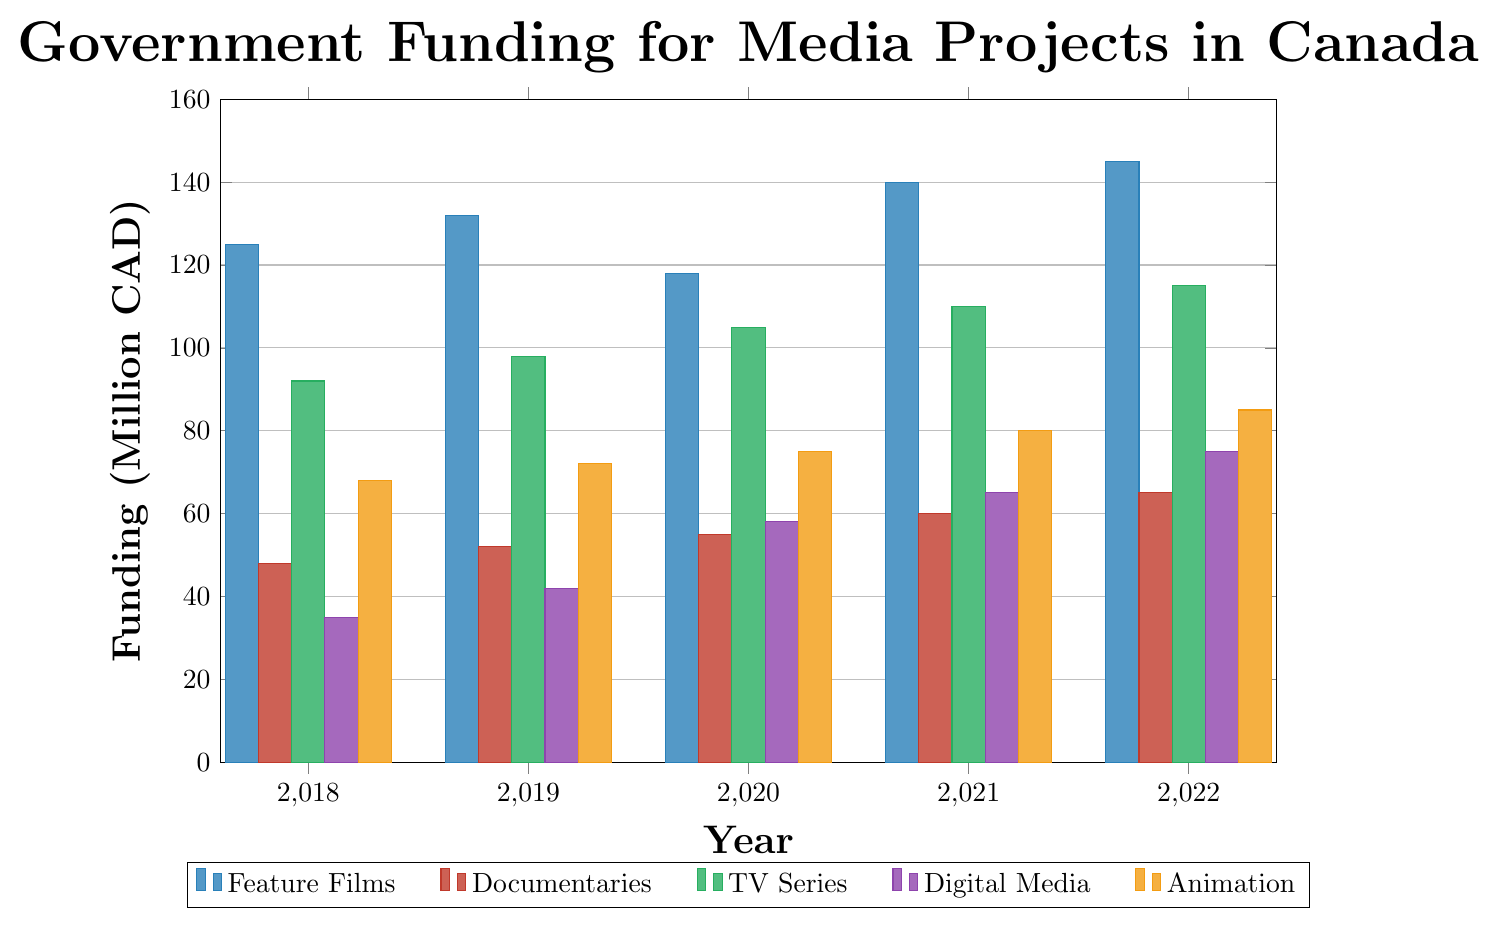How much funding was allocated to Feature Films in 2019? Locate the bar corresponding to Feature Films for the year 2019; the height represents the funding amount in million CAD.
Answer: 132 Which type of media project had the highest funding in 2022? Compare the heights of the bars for 2022 across all media types to identify the tallest one.
Answer: Feature Films By how much did funding for Digital Media increase from 2018 to 2022? Subtract the funding amount for Digital Media in 2018 from that in 2022 (75 - 35).
Answer: 40 Did the funding for Animation exceed 80 million CAD in any year? Check the height of the bars for Animation across all given years to see if any exceeds 80.
Answer: Yes, in 2021 and 2022 What is the average funding allocated to Documentaries from 2018 to 2022? Sum the funding amounts for Documentaries for all given years and divide by the number of years (48 + 52 + 55 + 60 + 65) / 5 = 56
Answer: 56 Which year saw the highest total funding across all media types? Sum the funding amounts for all media types for each year and compare these sums to find the highest. The total funding for each year is: 2018: 368, 2019: 396, 2020: 411, 2021: 455, 2022: 485. The highest total funding is in 2022.
Answer: 2022 Compare the funding for TV Series and Feature Films in 2020. Which received more funding and by how much? Subtract the funding for TV Series from that for Feature Films in 2020 (118 - 105).
Answer: Feature Films by 13 million CAD Which type of media had the steadiest growth in funding from 2018 to 2022? Identify the media type with the most consistent year-over-year increase, which can be seen from steady increments in bar heights.
Answer: Documentaries By what percentage did the funding for Animation increase from 2018 to 2022? Calculate the percentage increase using the formula ((new amount - old amount) / old amount) * 100; for Animation ((85 - 68) / 68) * 100 = 25%
Answer: 25% Which year had the lowest funding for Digital Media, and what was the amount? Find the shortest bar for Digital Media across all years and read its height.
Answer: 2018, 35 million CAD 